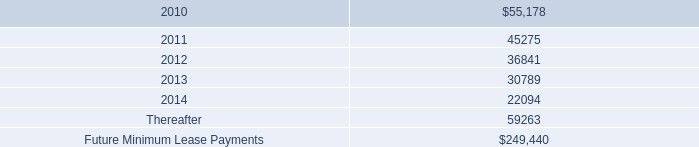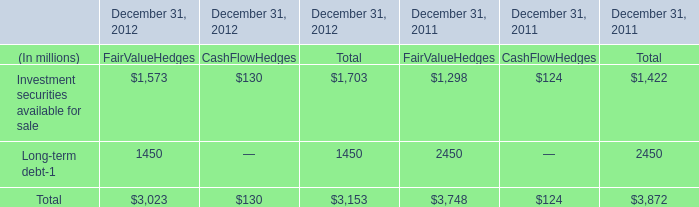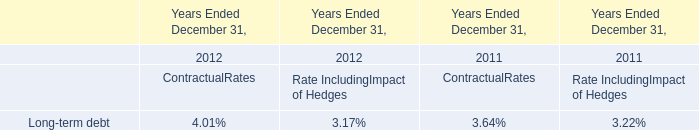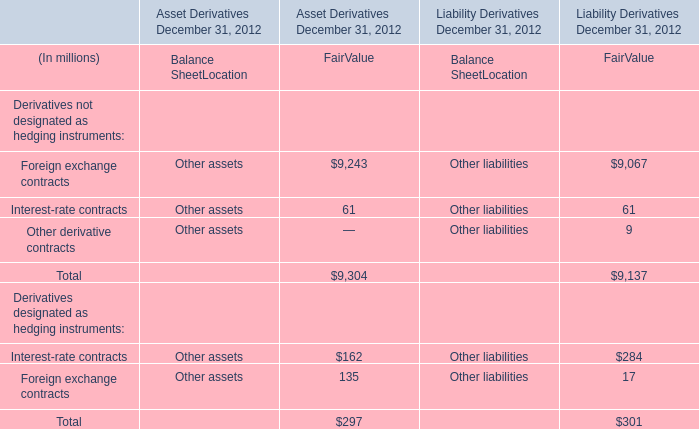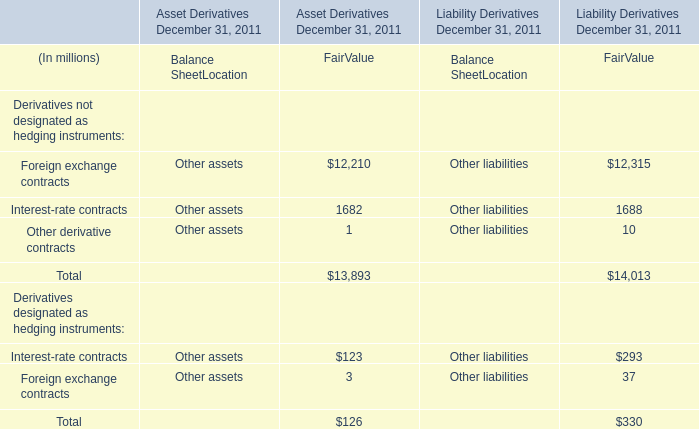What is the 50% of the highest Fair Value for Derivatives designated as hedging instruments:Interest-rate contracts as As the chart 3 shows? (in million) 
Computations: (0.5 * 284)
Answer: 142.0. 